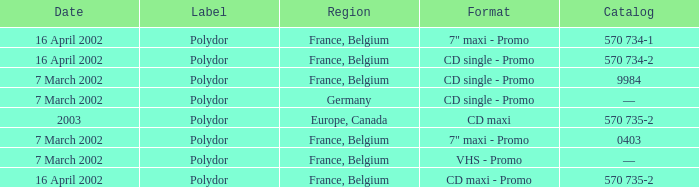Which region had a release format of CD Maxi? Europe, Canada. 